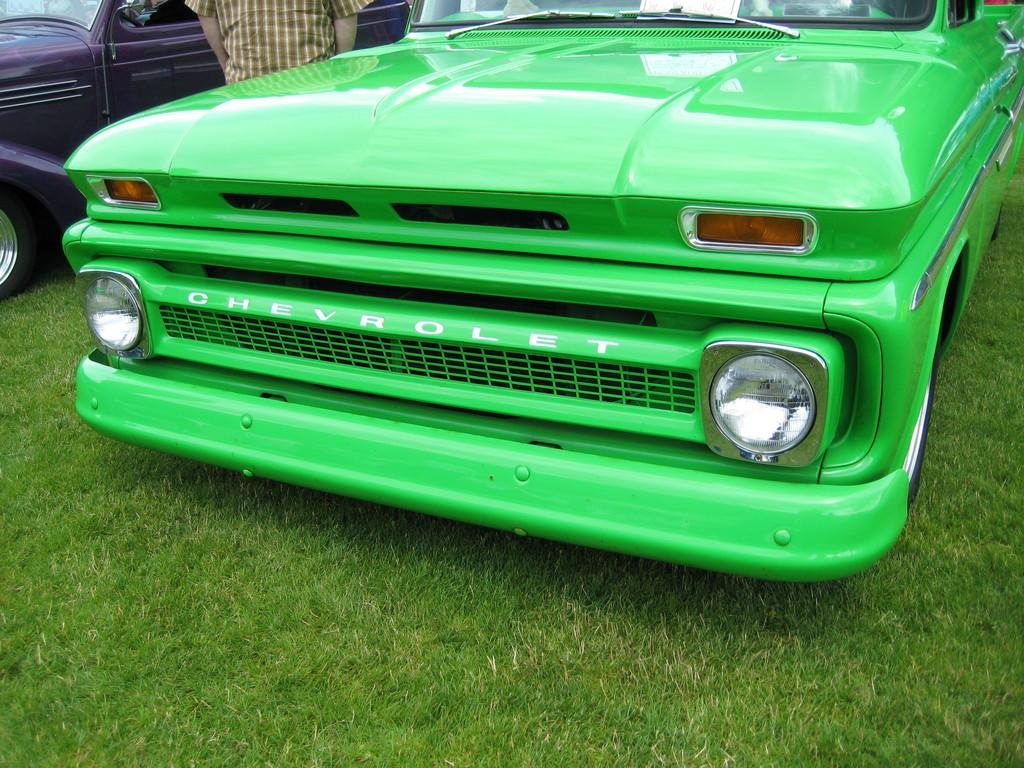What types of objects are present in the image? There are vehicles and a person in the image. What is the setting of the image? The image features grass at the bottom, suggesting an outdoor setting. What type of patch is being sewn onto the person's clothing in the image? There is no patch or sewing activity present in the image. 